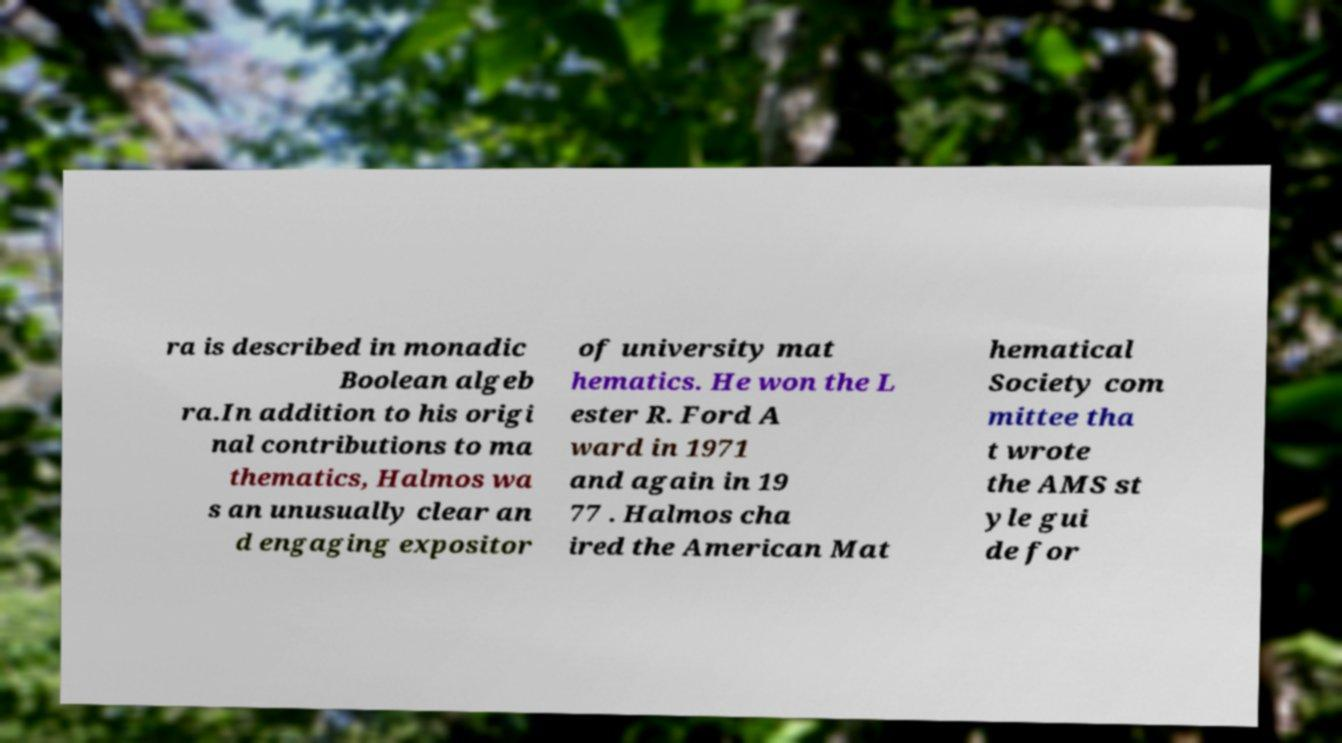I need the written content from this picture converted into text. Can you do that? ra is described in monadic Boolean algeb ra.In addition to his origi nal contributions to ma thematics, Halmos wa s an unusually clear an d engaging expositor of university mat hematics. He won the L ester R. Ford A ward in 1971 and again in 19 77 . Halmos cha ired the American Mat hematical Society com mittee tha t wrote the AMS st yle gui de for 